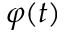<formula> <loc_0><loc_0><loc_500><loc_500>\varphi ( t )</formula> 